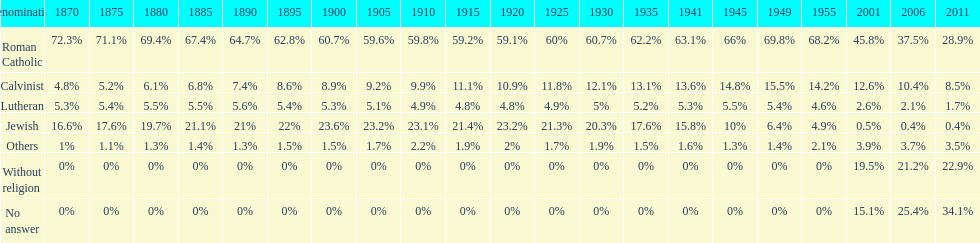In what year was the fraction of those unaffiliated with any religion at least 20%? 2011. 